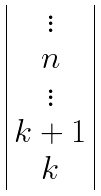<formula> <loc_0><loc_0><loc_500><loc_500>\begin{array} { | c | } \vdots \\ n \\ \vdots \\ k + 1 \\ k \\ \end{array}</formula> 